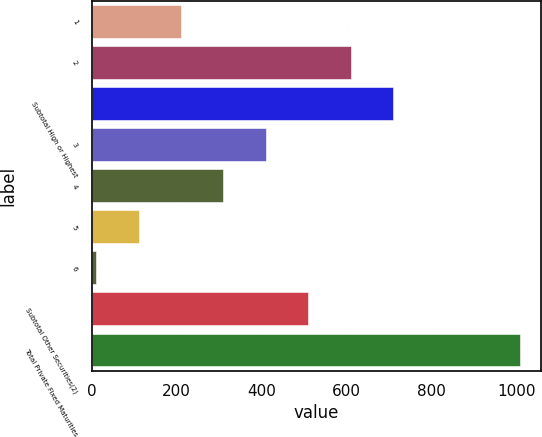Convert chart. <chart><loc_0><loc_0><loc_500><loc_500><bar_chart><fcel>1<fcel>2<fcel>Subtotal High or Highest<fcel>3<fcel>4<fcel>5<fcel>6<fcel>Subtotal Other Securities(2)<fcel>Total Private Fixed Maturities<nl><fcel>210.2<fcel>608.6<fcel>708.2<fcel>409.4<fcel>309.8<fcel>110.6<fcel>11<fcel>509<fcel>1007<nl></chart> 